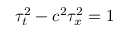Convert formula to latex. <formula><loc_0><loc_0><loc_500><loc_500>\tau _ { t } ^ { 2 } - c ^ { 2 } \tau _ { x } ^ { 2 } = 1</formula> 